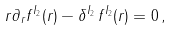Convert formula to latex. <formula><loc_0><loc_0><loc_500><loc_500>r \partial _ { r } f ^ { I _ { 2 } } ( r ) - \delta ^ { I _ { 2 } } \, f ^ { I _ { 2 } } ( r ) = 0 \, ,</formula> 